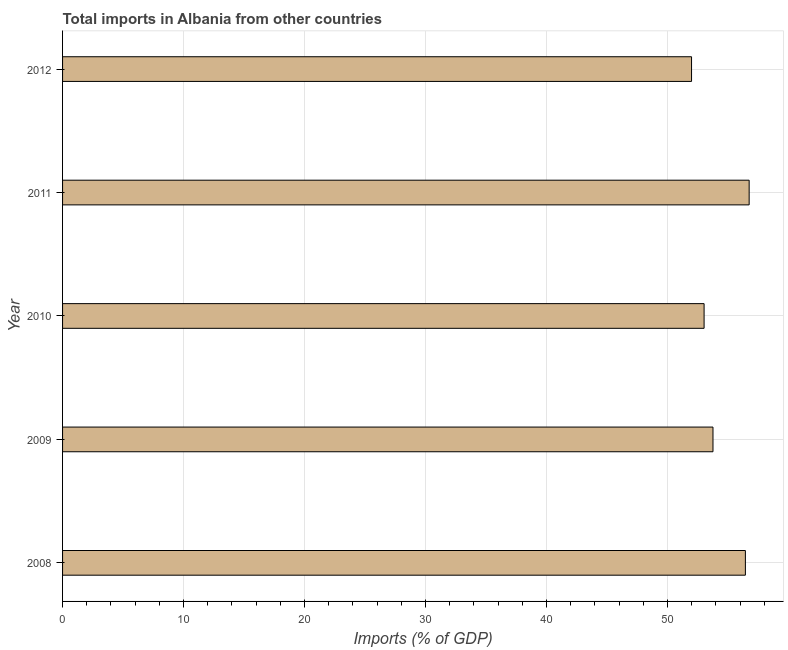Does the graph contain any zero values?
Make the answer very short. No. What is the title of the graph?
Provide a short and direct response. Total imports in Albania from other countries. What is the label or title of the X-axis?
Provide a succinct answer. Imports (% of GDP). What is the total imports in 2011?
Give a very brief answer. 56.75. Across all years, what is the maximum total imports?
Your answer should be compact. 56.75. Across all years, what is the minimum total imports?
Keep it short and to the point. 51.99. In which year was the total imports minimum?
Provide a short and direct response. 2012. What is the sum of the total imports?
Offer a terse response. 271.96. What is the difference between the total imports in 2009 and 2010?
Keep it short and to the point. 0.73. What is the average total imports per year?
Your answer should be compact. 54.39. What is the median total imports?
Offer a terse response. 53.76. Do a majority of the years between 2009 and 2011 (inclusive) have total imports greater than 32 %?
Your response must be concise. Yes. What is the ratio of the total imports in 2008 to that in 2012?
Keep it short and to the point. 1.09. What is the difference between the highest and the second highest total imports?
Your answer should be compact. 0.31. Is the sum of the total imports in 2011 and 2012 greater than the maximum total imports across all years?
Provide a succinct answer. Yes. What is the difference between the highest and the lowest total imports?
Give a very brief answer. 4.76. In how many years, is the total imports greater than the average total imports taken over all years?
Provide a short and direct response. 2. Are all the bars in the graph horizontal?
Make the answer very short. Yes. What is the Imports (% of GDP) of 2008?
Give a very brief answer. 56.44. What is the Imports (% of GDP) of 2009?
Offer a very short reply. 53.76. What is the Imports (% of GDP) in 2010?
Your answer should be compact. 53.02. What is the Imports (% of GDP) of 2011?
Ensure brevity in your answer.  56.75. What is the Imports (% of GDP) in 2012?
Make the answer very short. 51.99. What is the difference between the Imports (% of GDP) in 2008 and 2009?
Make the answer very short. 2.68. What is the difference between the Imports (% of GDP) in 2008 and 2010?
Your response must be concise. 3.41. What is the difference between the Imports (% of GDP) in 2008 and 2011?
Provide a short and direct response. -0.31. What is the difference between the Imports (% of GDP) in 2008 and 2012?
Provide a short and direct response. 4.45. What is the difference between the Imports (% of GDP) in 2009 and 2010?
Your answer should be very brief. 0.73. What is the difference between the Imports (% of GDP) in 2009 and 2011?
Your answer should be very brief. -2.99. What is the difference between the Imports (% of GDP) in 2009 and 2012?
Offer a very short reply. 1.77. What is the difference between the Imports (% of GDP) in 2010 and 2011?
Provide a succinct answer. -3.72. What is the difference between the Imports (% of GDP) in 2010 and 2012?
Make the answer very short. 1.04. What is the difference between the Imports (% of GDP) in 2011 and 2012?
Your answer should be very brief. 4.76. What is the ratio of the Imports (% of GDP) in 2008 to that in 2010?
Your response must be concise. 1.06. What is the ratio of the Imports (% of GDP) in 2008 to that in 2012?
Your answer should be compact. 1.09. What is the ratio of the Imports (% of GDP) in 2009 to that in 2010?
Your response must be concise. 1.01. What is the ratio of the Imports (% of GDP) in 2009 to that in 2011?
Keep it short and to the point. 0.95. What is the ratio of the Imports (% of GDP) in 2009 to that in 2012?
Give a very brief answer. 1.03. What is the ratio of the Imports (% of GDP) in 2010 to that in 2011?
Ensure brevity in your answer.  0.93. What is the ratio of the Imports (% of GDP) in 2010 to that in 2012?
Your response must be concise. 1.02. What is the ratio of the Imports (% of GDP) in 2011 to that in 2012?
Your answer should be compact. 1.09. 